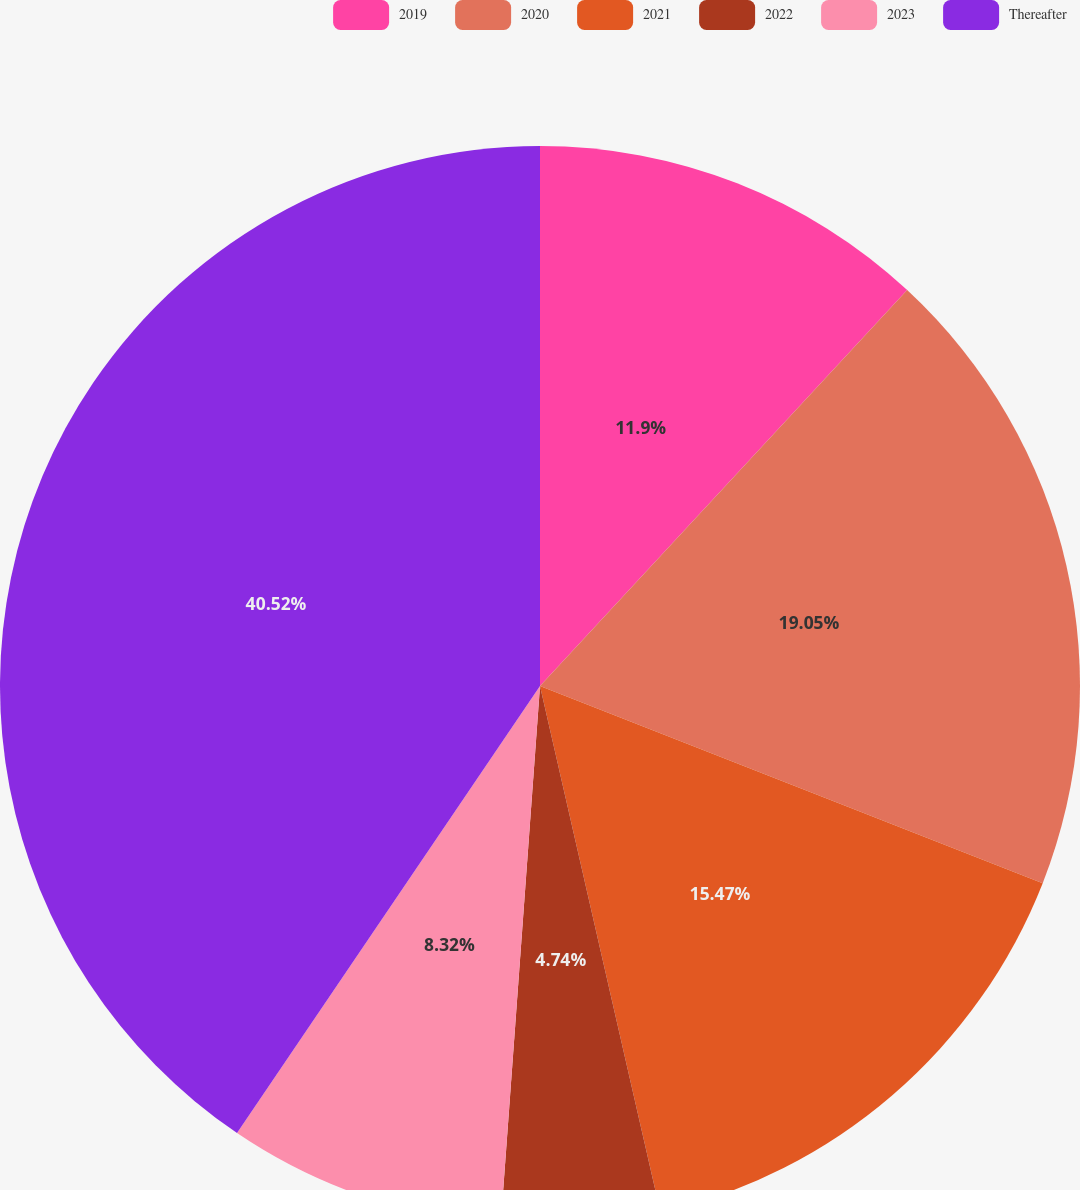Convert chart. <chart><loc_0><loc_0><loc_500><loc_500><pie_chart><fcel>2019<fcel>2020<fcel>2021<fcel>2022<fcel>2023<fcel>Thereafter<nl><fcel>11.9%<fcel>19.05%<fcel>15.47%<fcel>4.74%<fcel>8.32%<fcel>40.52%<nl></chart> 